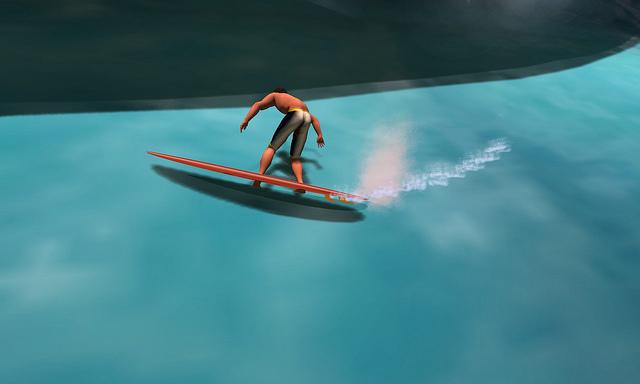Is this a real person?
Be succinct. No. Is this a computer-generated image?
Write a very short answer. Yes. Why is the man bending over?
Keep it brief. Surfing. 